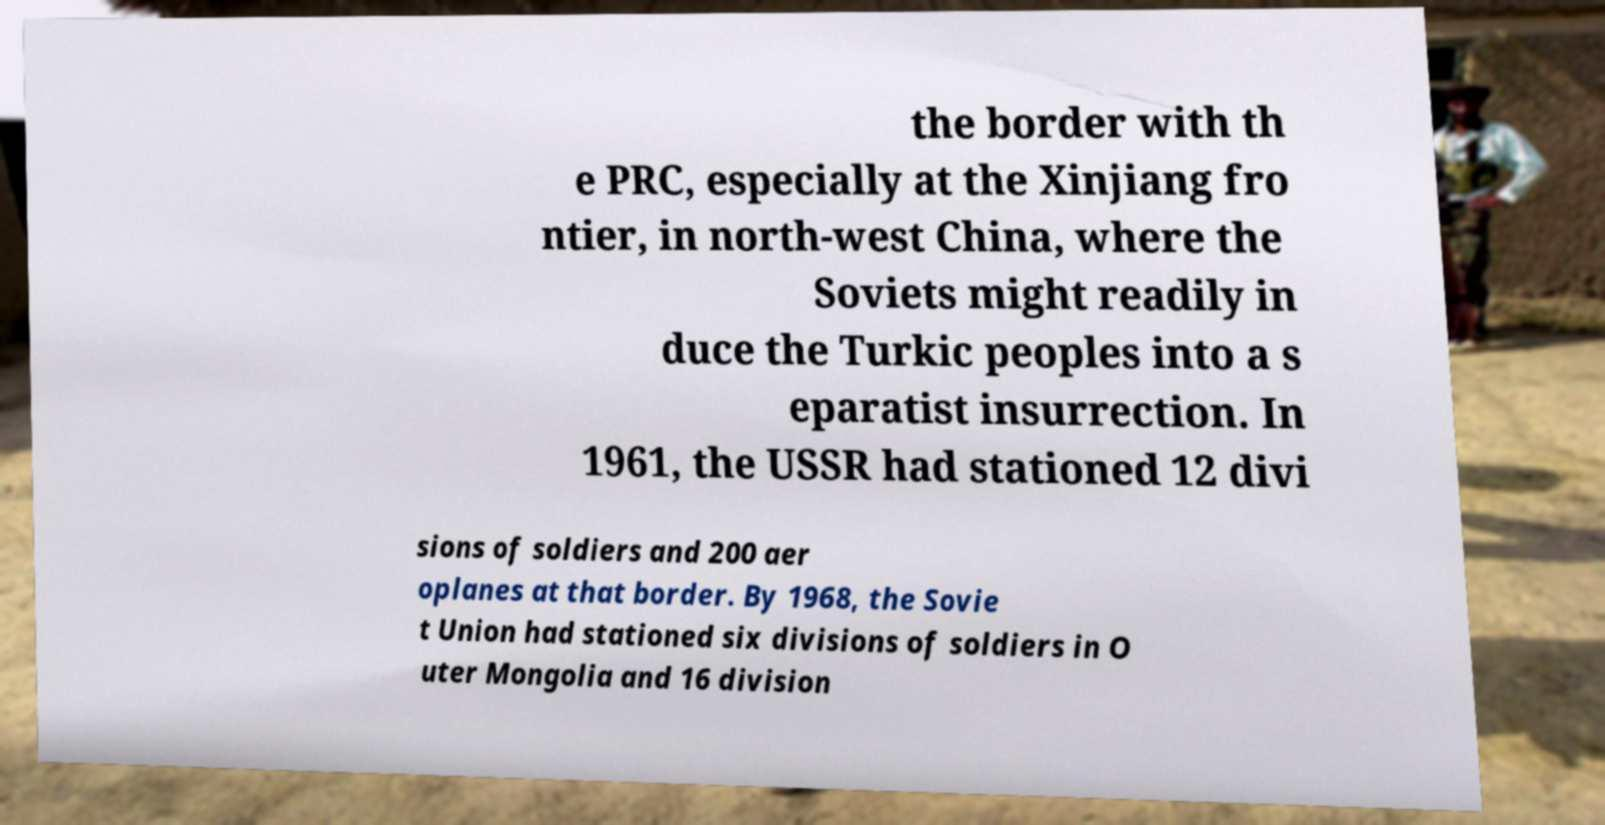Can you read and provide the text displayed in the image?This photo seems to have some interesting text. Can you extract and type it out for me? the border with th e PRC, especially at the Xinjiang fro ntier, in north-west China, where the Soviets might readily in duce the Turkic peoples into a s eparatist insurrection. In 1961, the USSR had stationed 12 divi sions of soldiers and 200 aer oplanes at that border. By 1968, the Sovie t Union had stationed six divisions of soldiers in O uter Mongolia and 16 division 